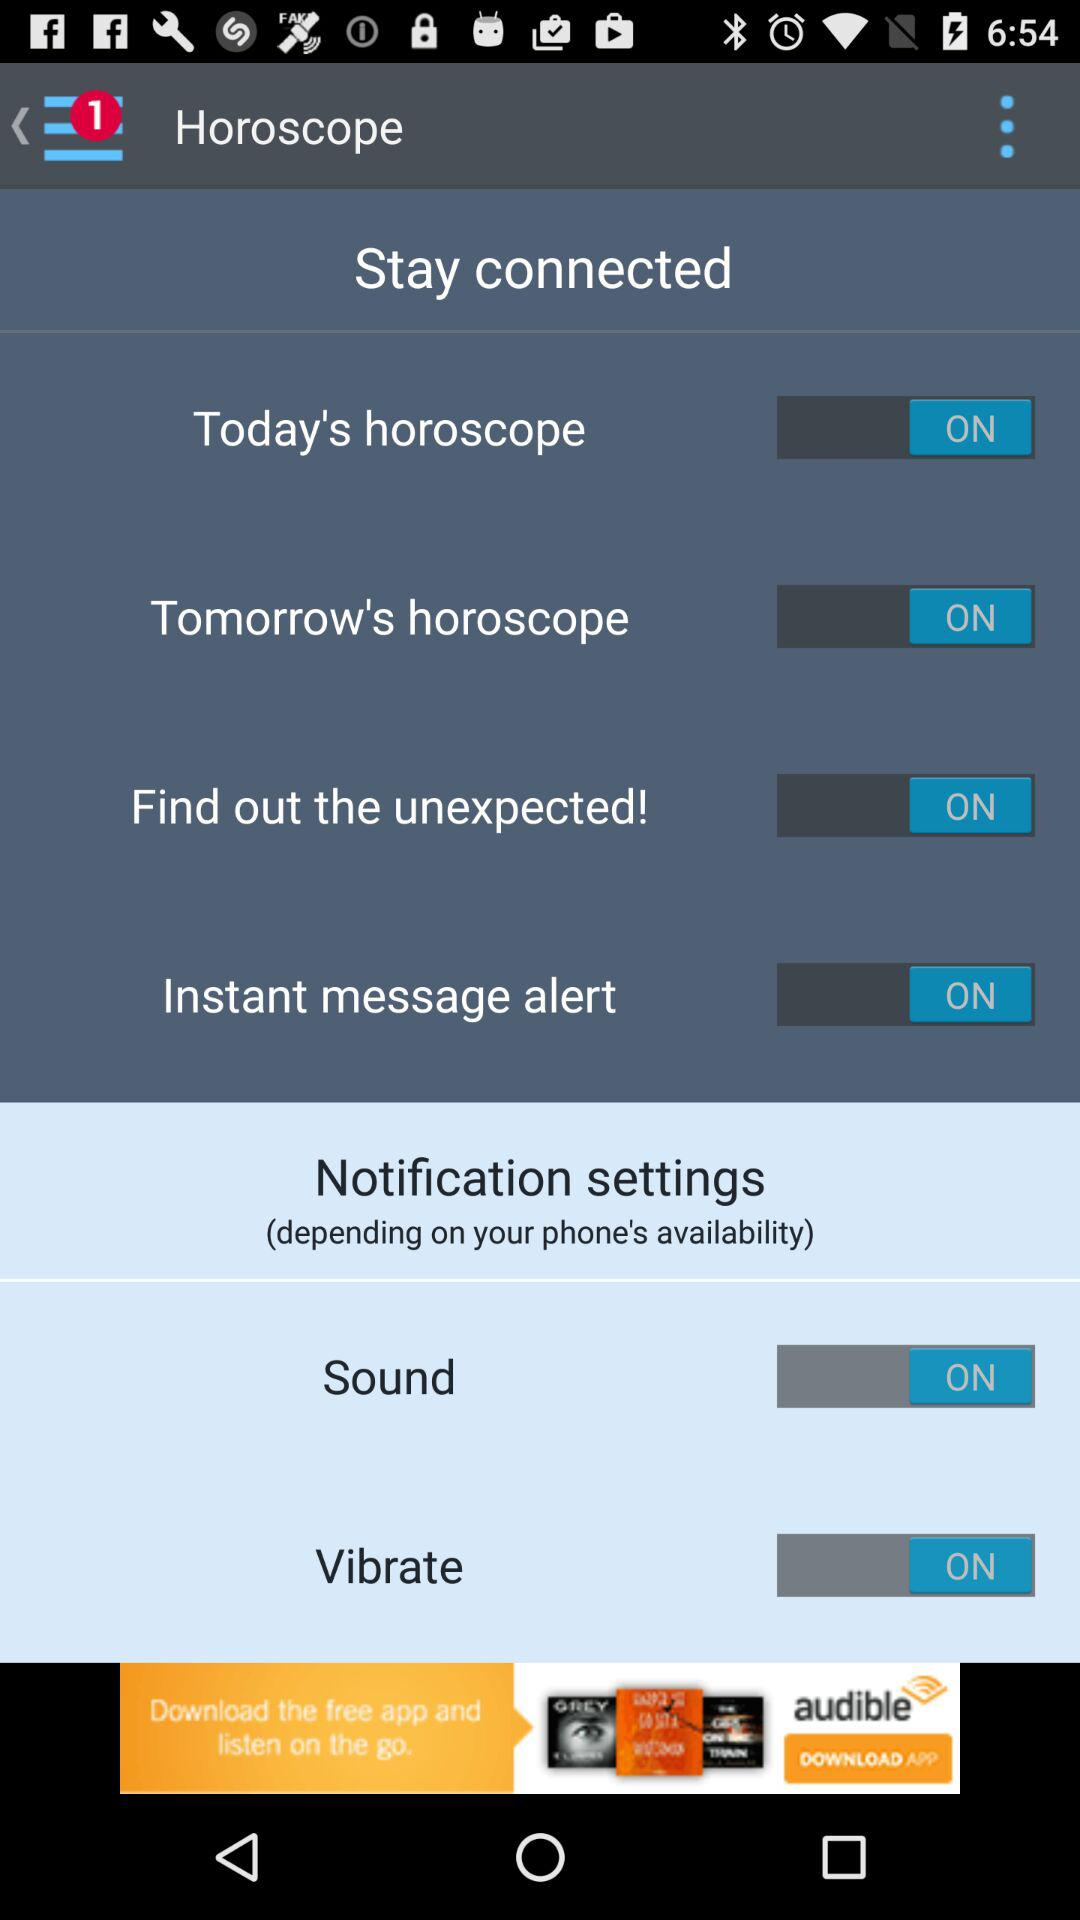What's the status of "Find out the unexpected!"? The status is "ON". 